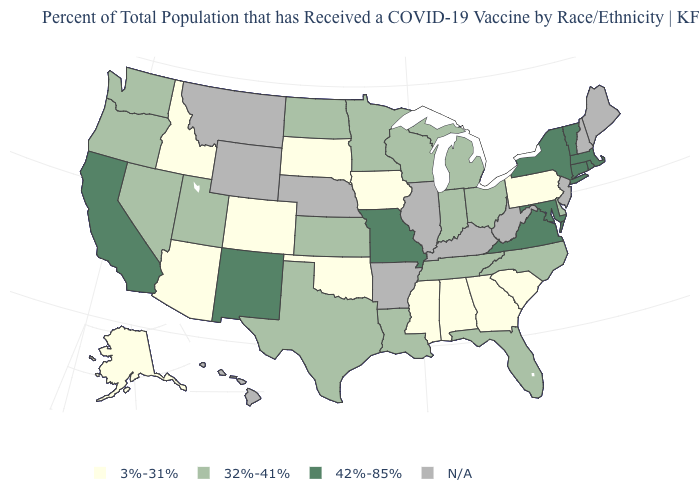Name the states that have a value in the range 32%-41%?
Write a very short answer. Delaware, Florida, Indiana, Kansas, Louisiana, Michigan, Minnesota, Nevada, North Carolina, North Dakota, Ohio, Oregon, Tennessee, Texas, Utah, Washington, Wisconsin. What is the value of Illinois?
Be succinct. N/A. Which states have the lowest value in the USA?
Be succinct. Alabama, Alaska, Arizona, Colorado, Georgia, Idaho, Iowa, Mississippi, Oklahoma, Pennsylvania, South Carolina, South Dakota. Among the states that border Alabama , which have the highest value?
Concise answer only. Florida, Tennessee. What is the value of Oregon?
Concise answer only. 32%-41%. Among the states that border North Carolina , does Virginia have the lowest value?
Concise answer only. No. Name the states that have a value in the range 42%-85%?
Write a very short answer. California, Connecticut, Maryland, Massachusetts, Missouri, New Mexico, New York, Rhode Island, Vermont, Virginia. Does North Carolina have the lowest value in the USA?
Quick response, please. No. What is the value of Nebraska?
Answer briefly. N/A. Among the states that border Kentucky , which have the lowest value?
Quick response, please. Indiana, Ohio, Tennessee. Among the states that border Vermont , which have the lowest value?
Answer briefly. Massachusetts, New York. Name the states that have a value in the range 3%-31%?
Short answer required. Alabama, Alaska, Arizona, Colorado, Georgia, Idaho, Iowa, Mississippi, Oklahoma, Pennsylvania, South Carolina, South Dakota. Does Indiana have the highest value in the USA?
Concise answer only. No. Does Missouri have the highest value in the USA?
Answer briefly. Yes. What is the value of Michigan?
Keep it brief. 32%-41%. 